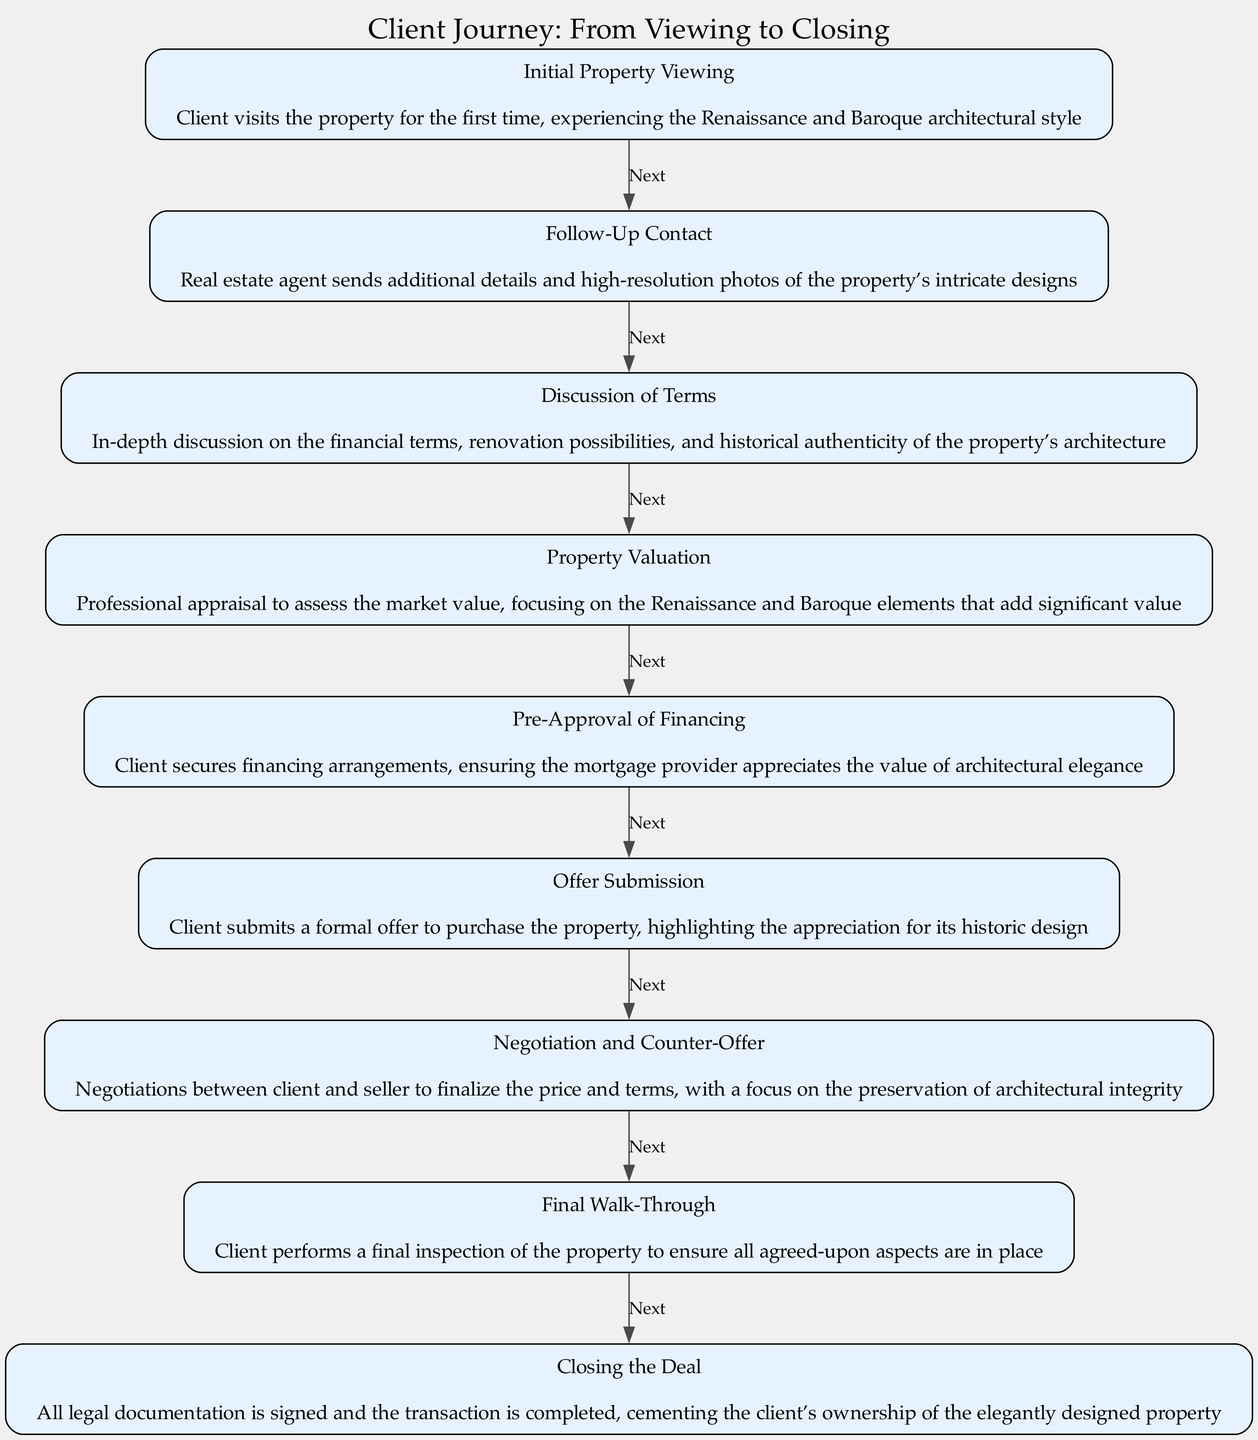What is the first step in the client journey? The initial step in the client journey is "Initial Property Viewing," where the client visits the property for the first time. This step is identified as the starting point in the flow chart.
Answer: Initial Property Viewing How many steps are there in total? By counting the nodes in the flow chart, there are nine distinct steps outlined in the journey from viewing to closing, each representing a key phase of the client experience.
Answer: Nine What comes after "Discussion of Terms"? Following "Discussion of Terms," the next step indicated in the flow chart is "Property Valuation." This step focuses on assessing the market value, as depicted in the diagram's flow.
Answer: Property Valuation What is the final step in the client journey? The last step depicted in the flow chart is "Closing the Deal," marking the completion of the entire process and the formal transfer of ownership.
Answer: Closing the Deal What is highlighted during "Final Walk-Through"? During the "Final Walk-Through," the client's focus is on ensuring that all agreed-upon aspects of the property are in place before the closing. This step emphasizes verifying condition and agreements made earlier in the process.
Answer: Inspection of agreed-upon aspects Which step involves securing financing arrangements? The step focused on securing financing arrangements is "Pre-Approval of Financing." At this stage, the client ensures that the mortgage provider understands the property’s value and historical significance.
Answer: Pre-Approval of Financing What is the primary focus during "Negotiation and Counter-Offer"? In "Negotiation and Counter-Offer," the primary focus is on finalizing the price and terms while ensuring the preservation of the property's architectural integrity. This node emphasizes the negotiations essential for reaching an agreement.
Answer: Preservation of architectural integrity What are the main aspects discussed in "Discussion of Terms"? In "Discussion of Terms," the key aspects include financial terms, renovation possibilities, and ensuring the historical authenticity of the property’s architecture, all of which are central to this stage of the journey.
Answer: Financial terms, renovation possibilities, historical authenticity What signifies the completion of the client's ownership transfer? The completion of the ownership transfer is signified by "Closing the Deal," where all legal documentation is finalized, marking the end of the client journey in the flow chart.
Answer: Legal documentation signed 